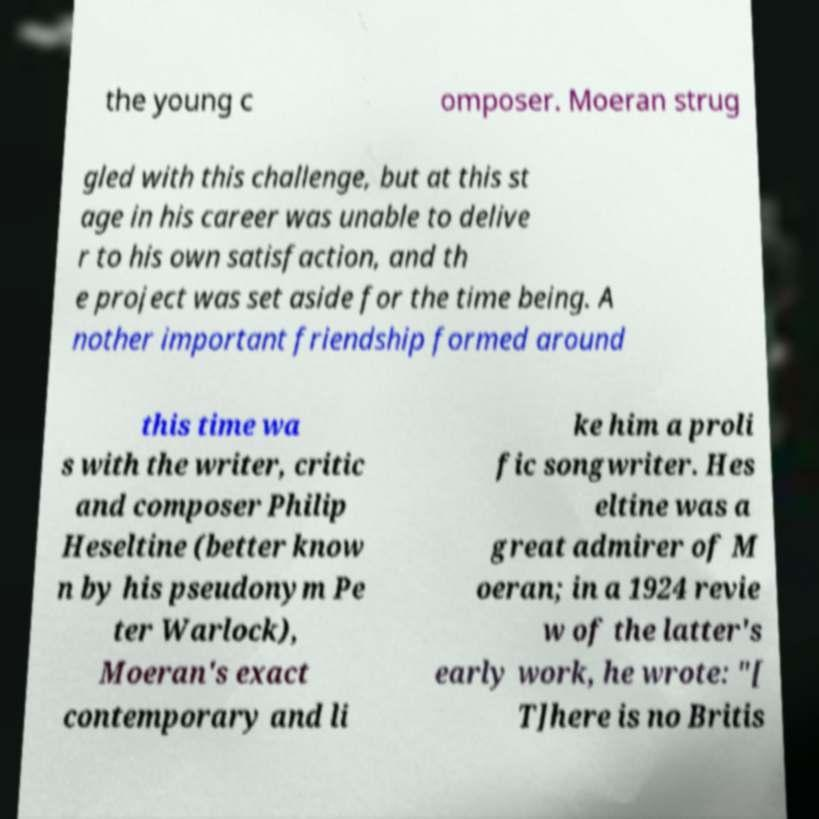There's text embedded in this image that I need extracted. Can you transcribe it verbatim? the young c omposer. Moeran strug gled with this challenge, but at this st age in his career was unable to delive r to his own satisfaction, and th e project was set aside for the time being. A nother important friendship formed around this time wa s with the writer, critic and composer Philip Heseltine (better know n by his pseudonym Pe ter Warlock), Moeran's exact contemporary and li ke him a proli fic songwriter. Hes eltine was a great admirer of M oeran; in a 1924 revie w of the latter's early work, he wrote: "[ T]here is no Britis 